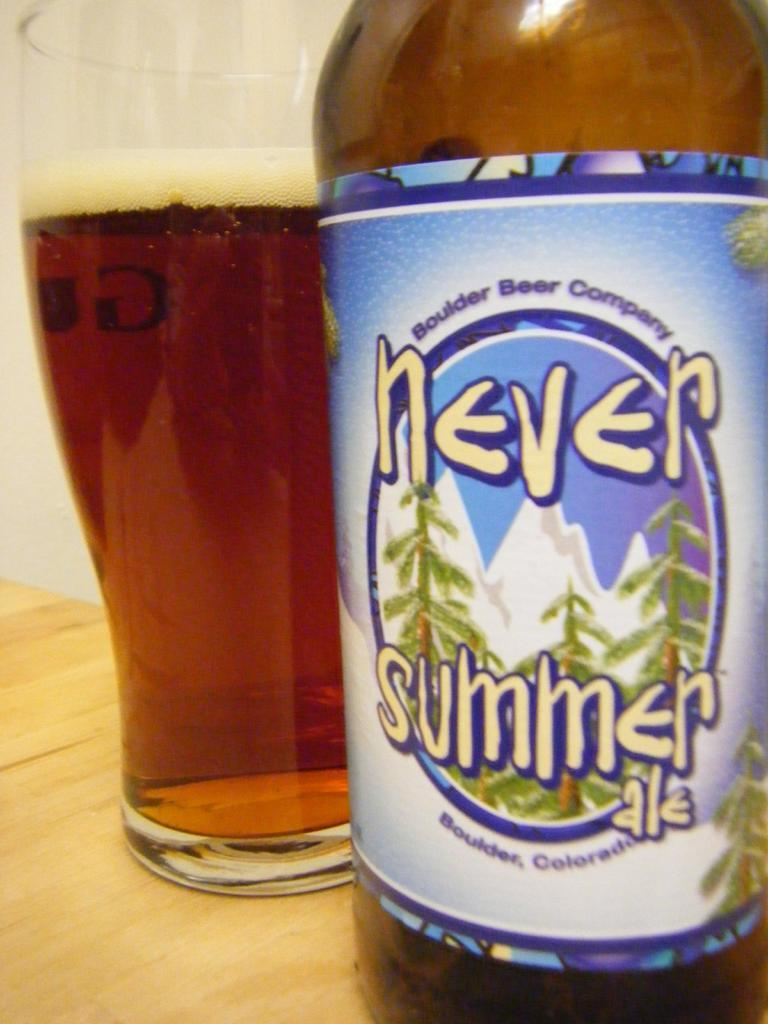<image>
Present a compact description of the photo's key features. A bottle has a label that says never summer and with trees on it. 